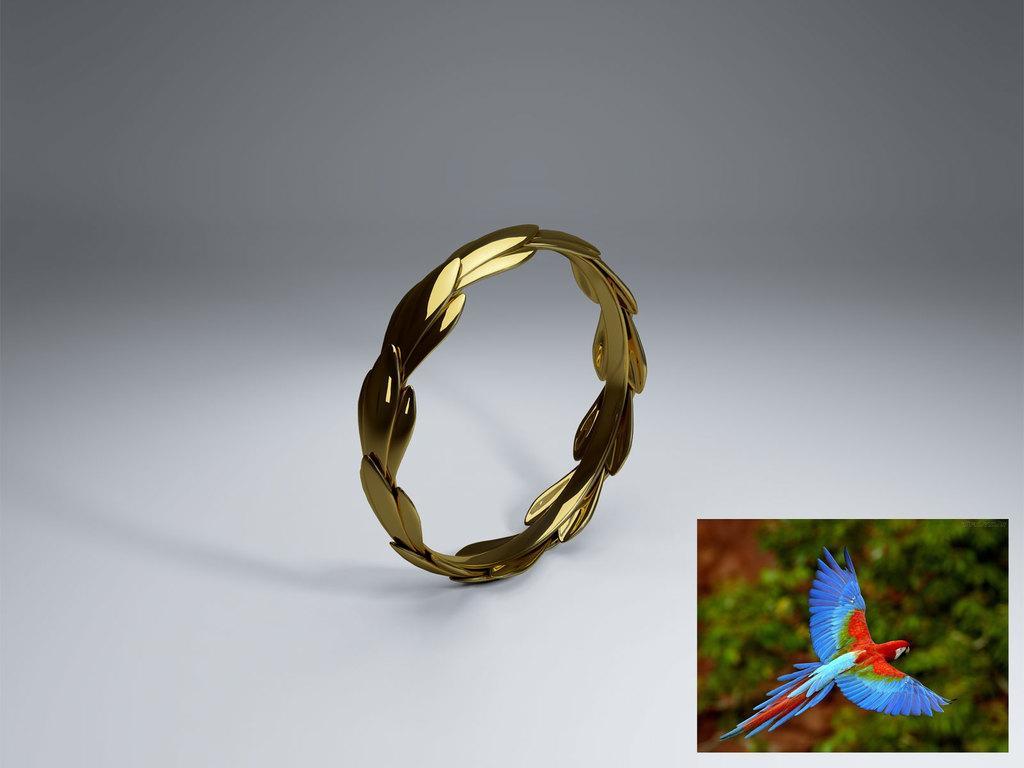Please provide a concise description of this image. In this image we can see a gold color bangle is kept on the white color surface. On the bottom right side of the image we can see a picture in which a bird is flying in the air and we can see the background is slightly blurred. 